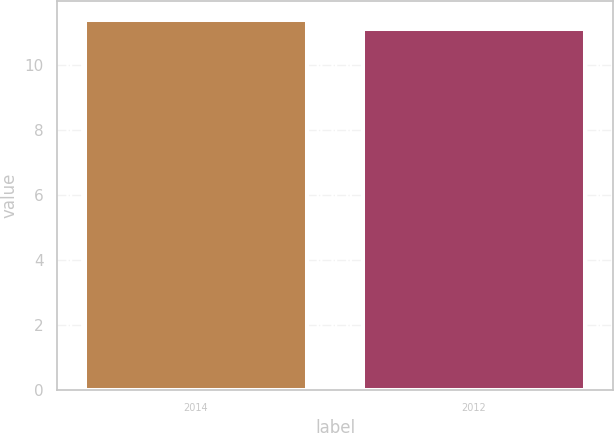<chart> <loc_0><loc_0><loc_500><loc_500><bar_chart><fcel>2014<fcel>2012<nl><fcel>11.4<fcel>11.1<nl></chart> 